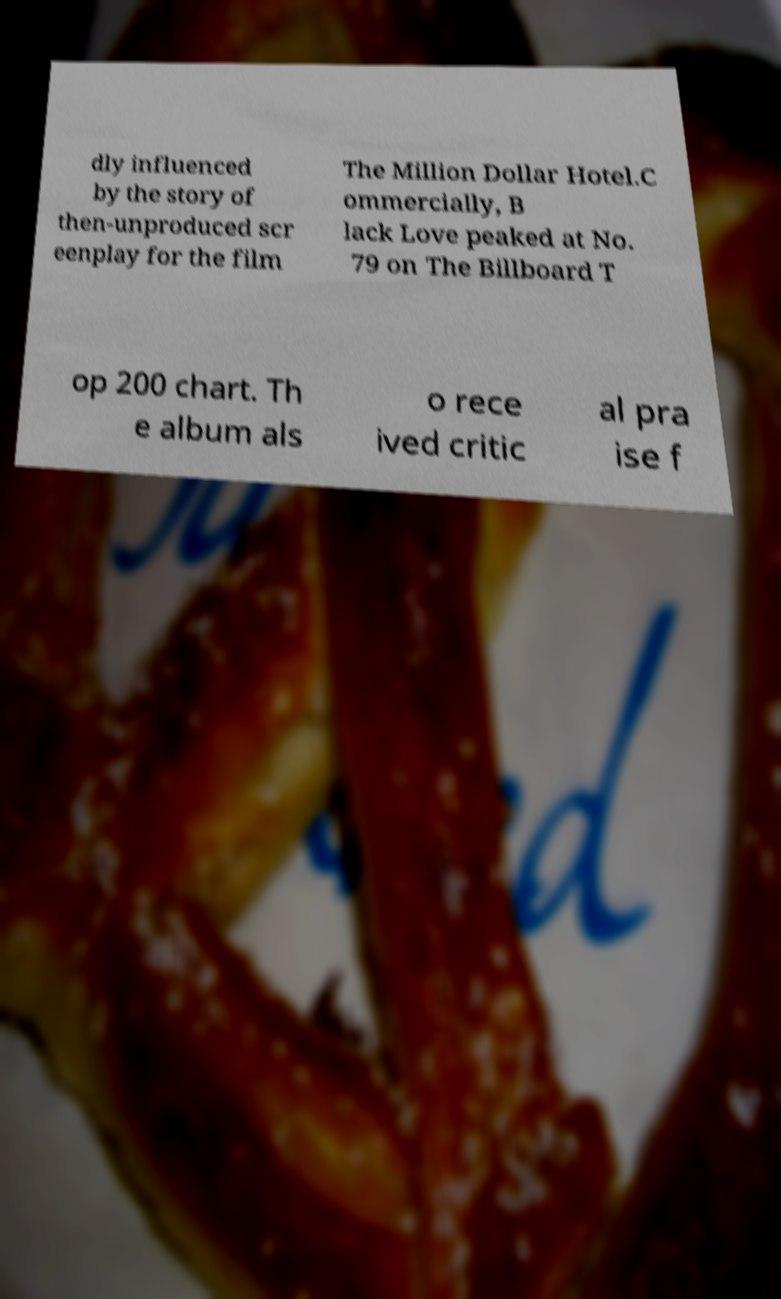Please identify and transcribe the text found in this image. dly influenced by the story of then-unproduced scr eenplay for the film The Million Dollar Hotel.C ommercially, B lack Love peaked at No. 79 on The Billboard T op 200 chart. Th e album als o rece ived critic al pra ise f 